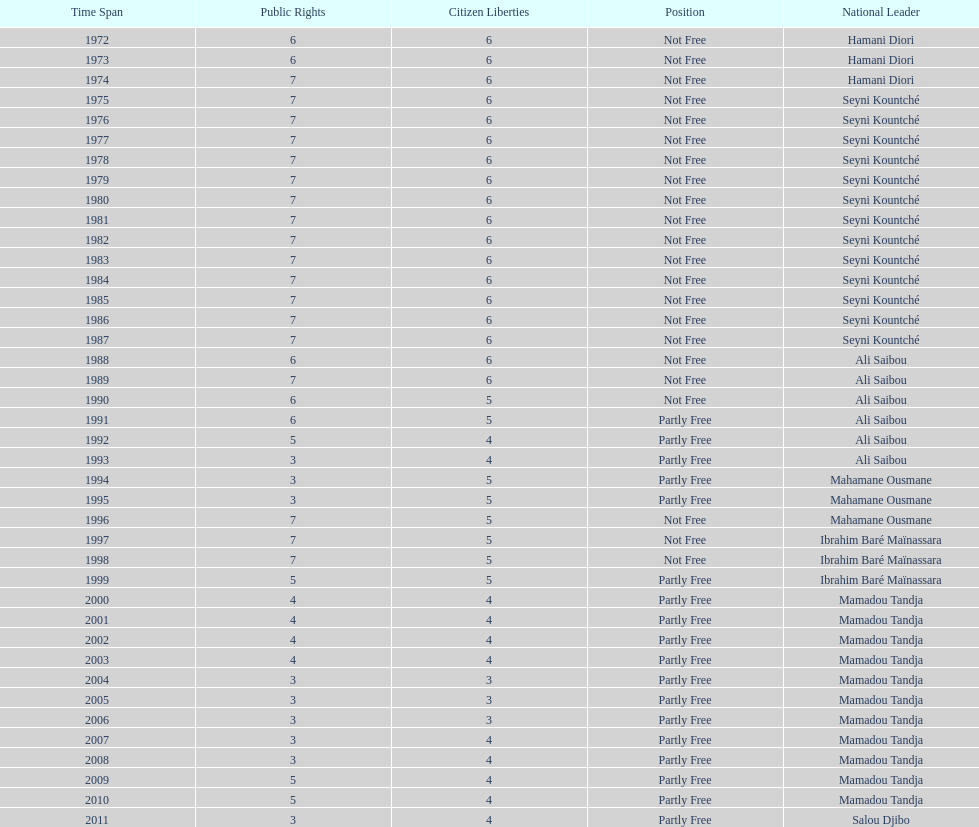How many times was the political rights listed as seven? 18. 